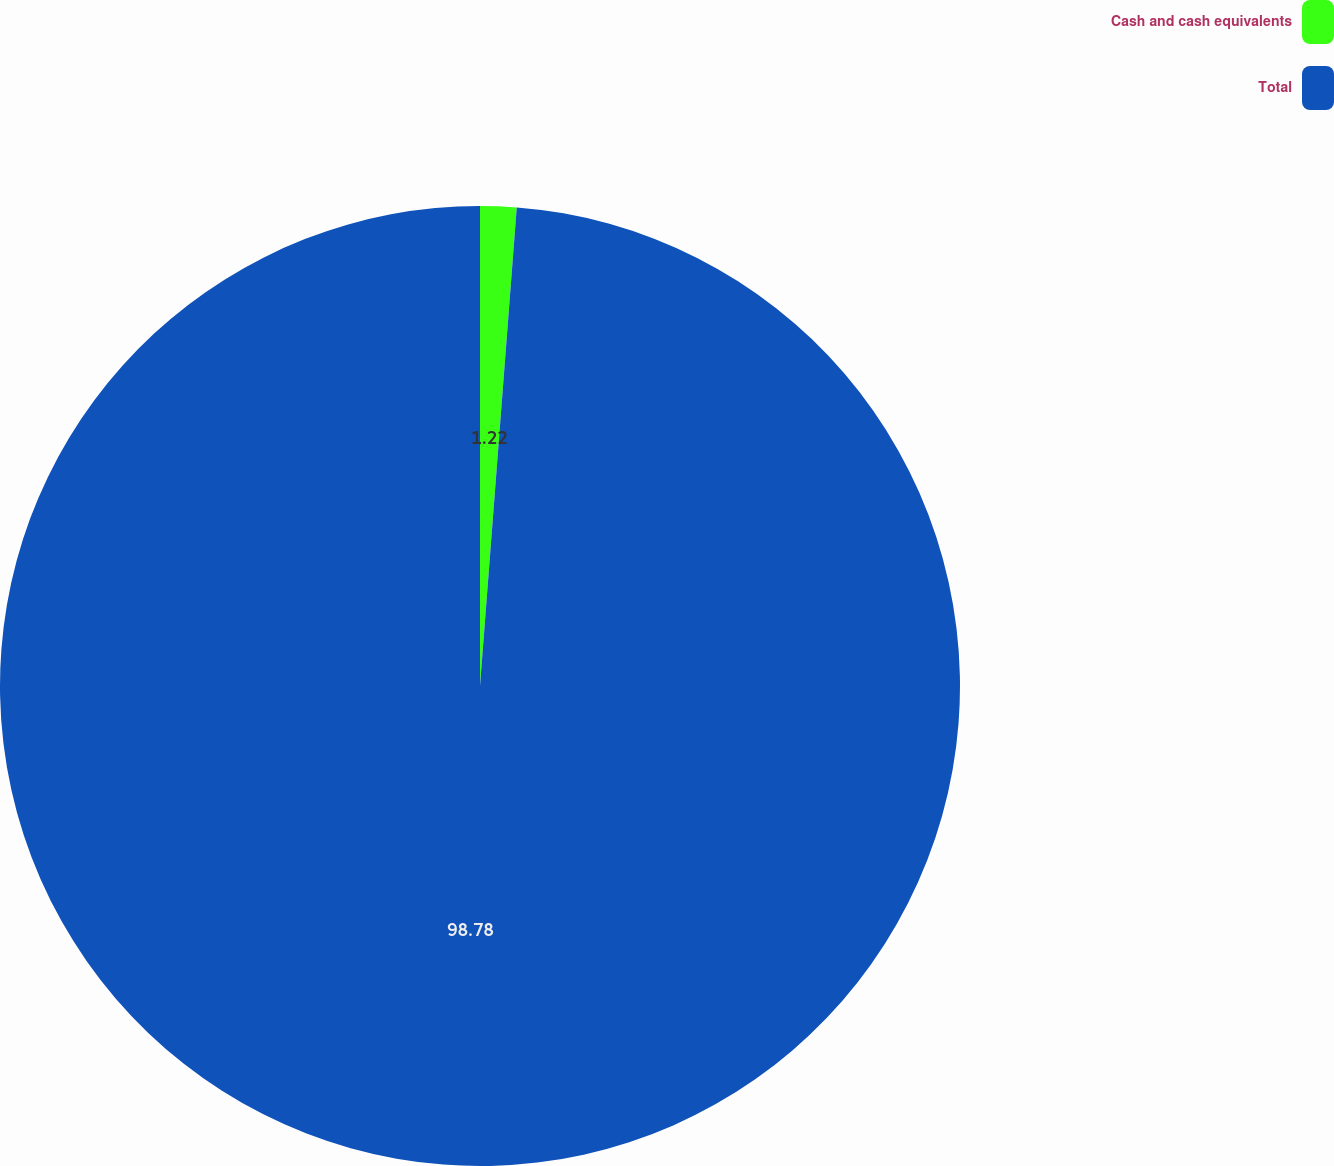<chart> <loc_0><loc_0><loc_500><loc_500><pie_chart><fcel>Cash and cash equivalents<fcel>Total<nl><fcel>1.22%<fcel>98.78%<nl></chart> 